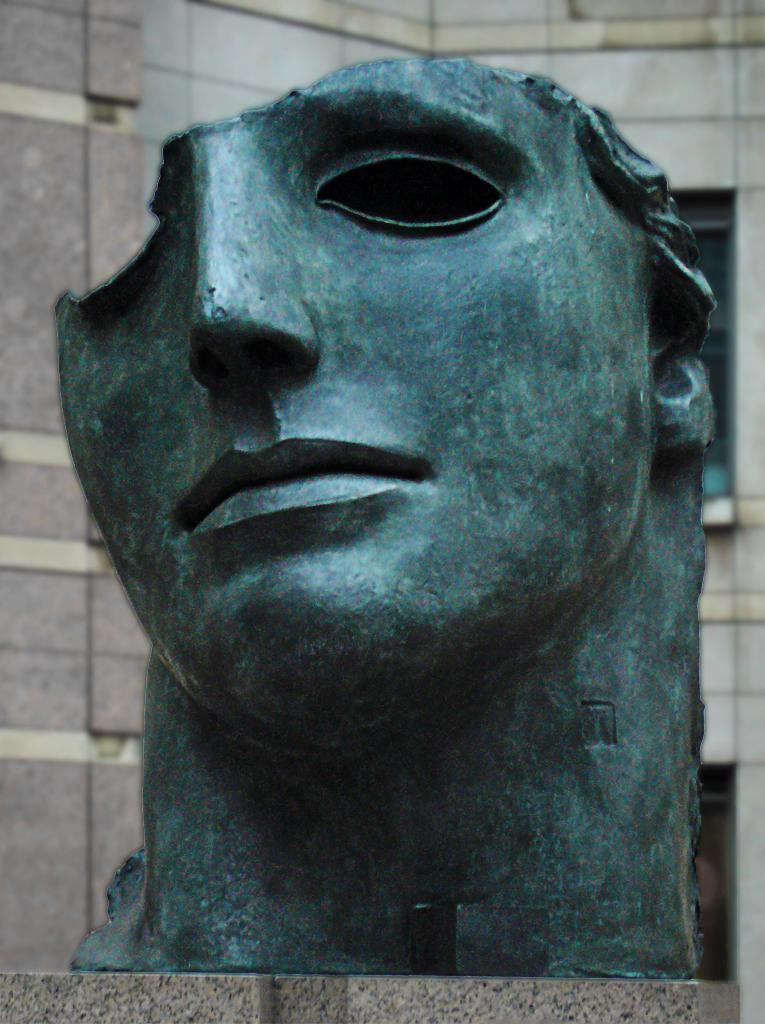Can you describe this image briefly? In this picture I can observe a sculpture of a human face. This is in green color. In the background there is a building. 